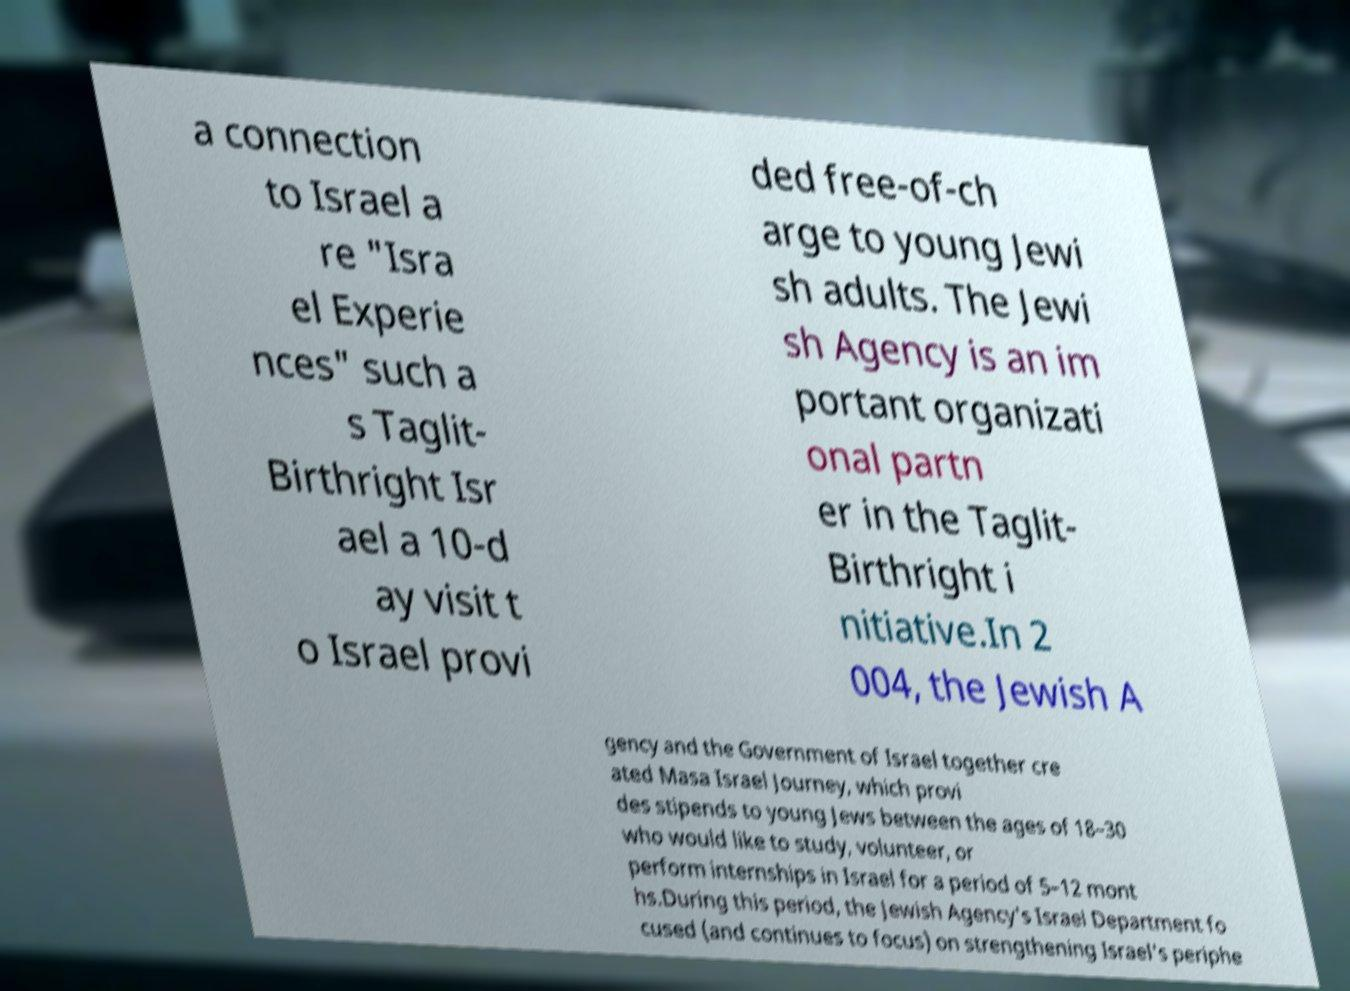There's text embedded in this image that I need extracted. Can you transcribe it verbatim? a connection to Israel a re "Isra el Experie nces" such a s Taglit- Birthright Isr ael a 10-d ay visit t o Israel provi ded free-of-ch arge to young Jewi sh adults. The Jewi sh Agency is an im portant organizati onal partn er in the Taglit- Birthright i nitiative.In 2 004, the Jewish A gency and the Government of Israel together cre ated Masa Israel Journey, which provi des stipends to young Jews between the ages of 18–30 who would like to study, volunteer, or perform internships in Israel for a period of 5–12 mont hs.During this period, the Jewish Agency's Israel Department fo cused (and continues to focus) on strengthening Israel's periphe 